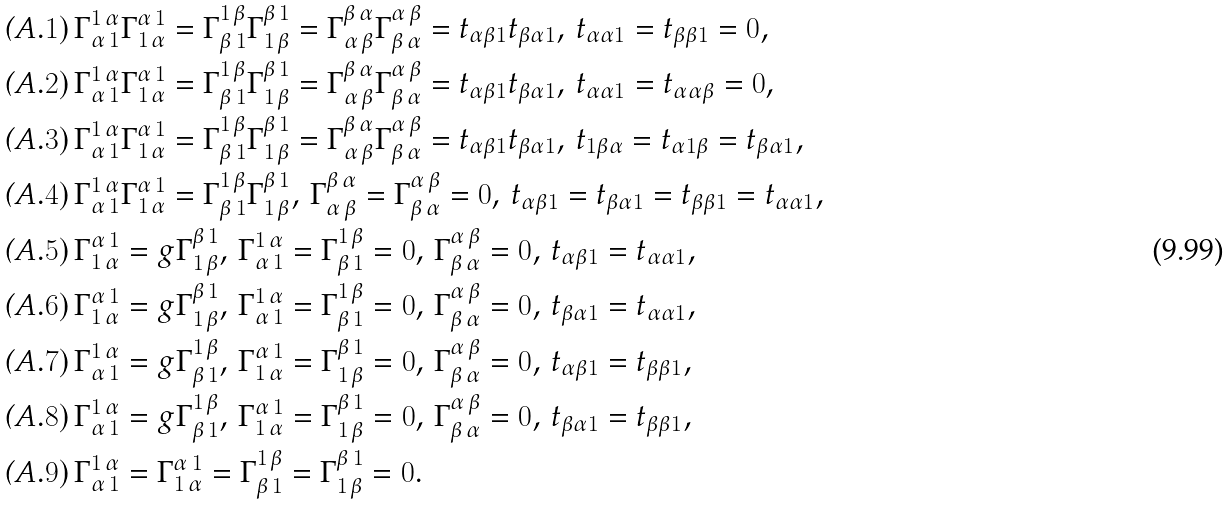Convert formula to latex. <formula><loc_0><loc_0><loc_500><loc_500>& { \mbox ( A . 1 ) } \, \Gamma _ { \alpha \, 1 } ^ { 1 \, \alpha } \Gamma _ { 1 \, \alpha } ^ { \alpha \, 1 } = \Gamma _ { \beta \, 1 } ^ { 1 \, \beta } \Gamma _ { 1 \, \beta } ^ { \beta \, 1 } = \Gamma _ { \alpha \, \beta } ^ { \beta \, \alpha } \Gamma _ { \beta \, \alpha } ^ { \alpha \, \beta } = t _ { \alpha \beta 1 } t _ { \beta \alpha 1 } , \, t _ { \alpha \alpha 1 } = t _ { \beta \beta 1 } = 0 , \\ & { \mbox ( A . 2 ) } \, \Gamma _ { \alpha \, 1 } ^ { 1 \, \alpha } \Gamma _ { 1 \, \alpha } ^ { \alpha \, 1 } = \Gamma _ { \beta \, 1 } ^ { 1 \, \beta } \Gamma _ { 1 \, \beta } ^ { \beta \, 1 } = \Gamma _ { \alpha \, \beta } ^ { \beta \, \alpha } \Gamma _ { \beta \, \alpha } ^ { \alpha \, \beta } = t _ { \alpha \beta 1 } t _ { \beta \alpha 1 } , \, t _ { \alpha \alpha 1 } = t _ { \alpha \alpha \beta } = 0 , \\ & { \mbox ( A . 3 ) } \, \Gamma _ { \alpha \, 1 } ^ { 1 \, \alpha } \Gamma _ { 1 \, \alpha } ^ { \alpha \, 1 } = \Gamma _ { \beta \, 1 } ^ { 1 \, \beta } \Gamma _ { 1 \, \beta } ^ { \beta \, 1 } = \Gamma _ { \alpha \, \beta } ^ { \beta \, \alpha } \Gamma _ { \beta \, \alpha } ^ { \alpha \, \beta } = t _ { \alpha \beta 1 } t _ { \beta \alpha 1 } , \, t _ { 1 \beta \alpha } = t _ { \alpha 1 \beta } = t _ { \beta \alpha 1 } , \\ & { \mbox ( A . 4 ) } \, \Gamma _ { \alpha \, 1 } ^ { 1 \, \alpha } \Gamma _ { 1 \, \alpha } ^ { \alpha \, 1 } = \Gamma _ { \beta \, 1 } ^ { 1 \, \beta } \Gamma _ { 1 \, \beta } ^ { \beta \, 1 } , \, \Gamma _ { \alpha \, \beta } ^ { \beta \, \alpha } = \Gamma _ { \beta \, \alpha } ^ { \alpha \, \beta } = 0 , \, t _ { \alpha \beta 1 } = t _ { \beta \alpha 1 } = t _ { \beta \beta 1 } = t _ { \alpha \alpha 1 } , \\ & { \mbox ( A . 5 ) } \, \Gamma _ { 1 \, \alpha } ^ { \alpha \, 1 } = g \Gamma _ { 1 \, \beta } ^ { \beta \, 1 } , \, \Gamma _ { \alpha \, 1 } ^ { 1 \, \alpha } = \Gamma _ { \beta \, 1 } ^ { 1 \, \beta } = 0 , \, \Gamma _ { \beta \, \alpha } ^ { \alpha \, \beta } = 0 , \, t _ { \alpha \beta 1 } = t _ { \alpha \alpha 1 } , \\ & { \mbox ( A . 6 ) } \, \Gamma _ { 1 \, \alpha } ^ { \alpha \, 1 } = g \Gamma _ { 1 \, \beta } ^ { \beta \, 1 } , \, \Gamma _ { \alpha \, 1 } ^ { 1 \, \alpha } = \Gamma _ { \beta \, 1 } ^ { 1 \, \beta } = 0 , \, \Gamma _ { \beta \, \alpha } ^ { \alpha \, \beta } = 0 , \, t _ { \beta \alpha 1 } = t _ { \alpha \alpha 1 } , \\ & { \mbox ( A . 7 ) } \, \Gamma _ { \alpha \, 1 } ^ { 1 \, \alpha } = g \Gamma _ { \beta \, 1 } ^ { 1 \, \beta } , \, \Gamma _ { 1 \, \alpha } ^ { \alpha \, 1 } = \Gamma _ { 1 \, \beta } ^ { \beta \, 1 } = 0 , \, \Gamma _ { \beta \, \alpha } ^ { \alpha \, \beta } = 0 , \, t _ { \alpha \beta 1 } = t _ { \beta \beta 1 } , \\ & { \mbox ( A . 8 ) } \, \Gamma _ { \alpha \, 1 } ^ { 1 \, \alpha } = g \Gamma _ { \beta \, 1 } ^ { 1 \, \beta } , \, \Gamma _ { 1 \, \alpha } ^ { \alpha \, 1 } = \Gamma _ { 1 \, \beta } ^ { \beta \, 1 } = 0 , \, \Gamma _ { \beta \, \alpha } ^ { \alpha \, \beta } = 0 , \, t _ { \beta \alpha 1 } = t _ { \beta \beta 1 } , \\ & { \mbox ( A . 9 ) } \, \Gamma _ { \alpha \, 1 } ^ { 1 \, \alpha } = \Gamma _ { 1 \, \alpha } ^ { \alpha \, 1 } = \Gamma _ { \beta \, 1 } ^ { 1 \, \beta } = \Gamma _ { 1 \, \beta } ^ { \beta \, 1 } = 0 .</formula> 